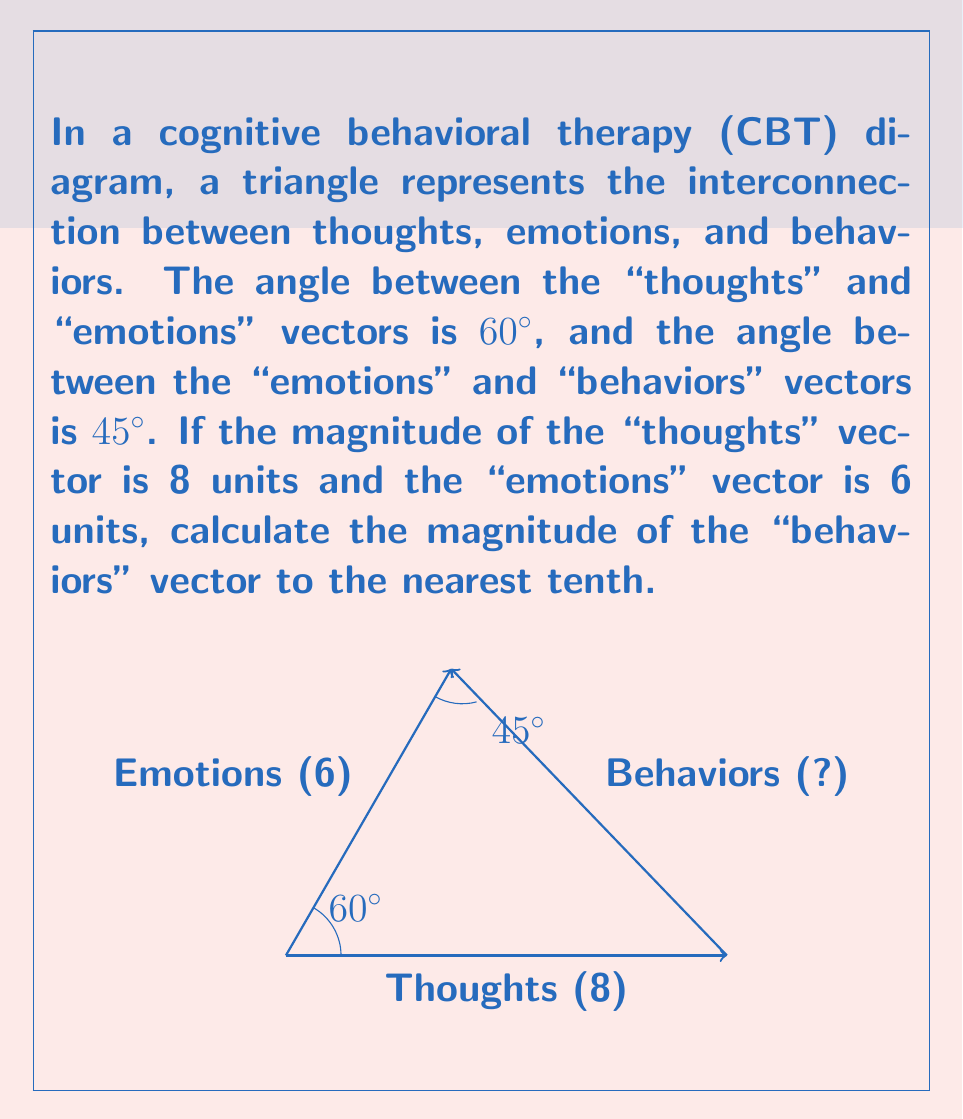Give your solution to this math problem. To solve this problem, we'll use the law of cosines. Let's approach this step-by-step:

1) Let's denote the magnitude of the "behaviors" vector as $x$.

2) The law of cosines states that in a triangle with sides $a$, $b$, and $c$, and an angle $C$ opposite the side $c$:

   $$c^2 = a^2 + b^2 - 2ab \cos(C)$$

3) In our case:
   $a = 8$ (thoughts vector)
   $b = 6$ (emotions vector)
   $c = x$ (behaviors vector, what we're solving for)
   $C = 180° - (60° + 45°) = 75°$ (the angle opposite the behaviors vector)

4) Substituting these values into the law of cosines:

   $$x^2 = 8^2 + 6^2 - 2(8)(6) \cos(75°)$$

5) Simplify:
   $$x^2 = 64 + 36 - 96 \cos(75°)$$

6) Calculate $\cos(75°)$ ≈ 0.2588

7) Substitute and simplify:
   $$x^2 = 64 + 36 - 96(0.2588) ≈ 75.1552$$

8) Take the square root of both sides:
   $$x ≈ \sqrt{75.1552} ≈ 8.6692$$

9) Rounding to the nearest tenth:
   $$x ≈ 8.7$$

Therefore, the magnitude of the "behaviors" vector is approximately 8.7 units.
Answer: 8.7 units 